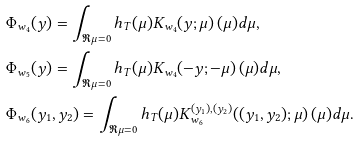<formula> <loc_0><loc_0><loc_500><loc_500>& \Phi _ { w _ { 4 } } ( y ) = \int _ { \Re \mu = 0 } h _ { T } ( \mu ) K _ { w _ { 4 } } ( y ; \mu ) \, ( \mu ) d \mu , \\ & \Phi _ { w _ { 5 } } ( y ) = \int _ { \Re \mu = 0 } h _ { T } ( \mu ) K _ { w _ { 4 } } ( - y ; - \mu ) \, ( \mu ) d \mu , \\ & \Phi _ { w _ { 6 } } ( y _ { 1 } , y _ { 2 } ) = \int _ { \Re \mu = 0 } h _ { T } ( \mu ) K ^ { ( y _ { 1 } ) , ( y _ { 2 } ) } _ { w _ { 6 } } ( ( y _ { 1 } , y _ { 2 } ) ; \mu ) \, ( \mu ) d \mu .</formula> 